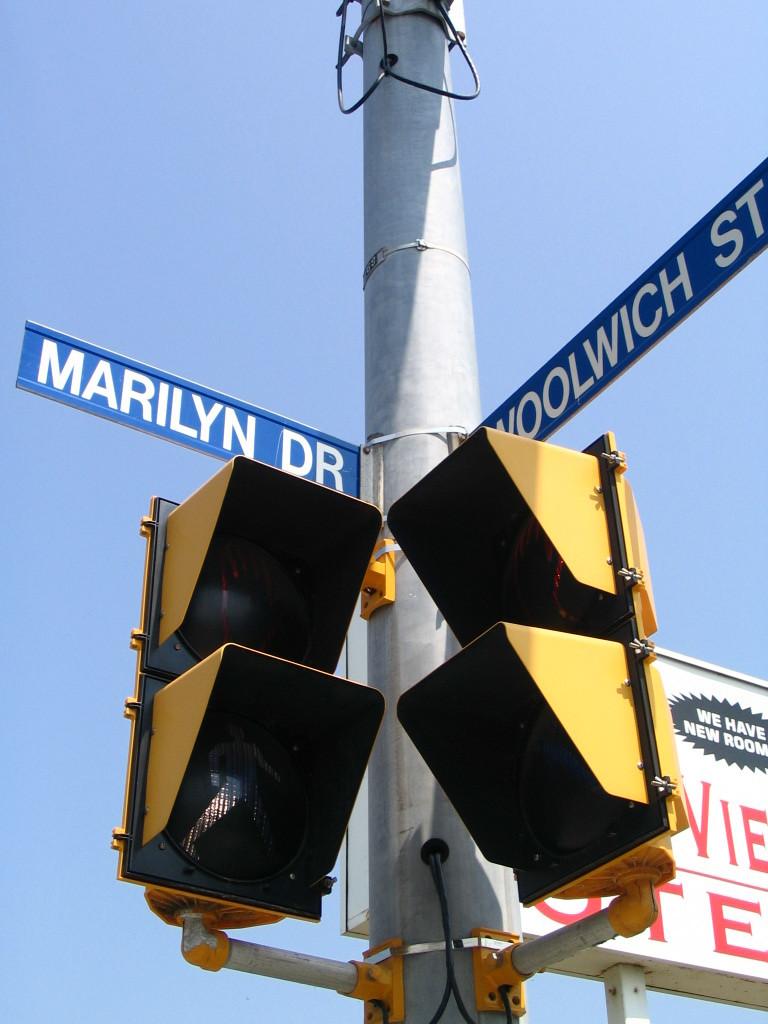What are the street names?
Ensure brevity in your answer.  Marilyn dr and woolwich st. What is in the black bubble on the sign in the back?
Your response must be concise. We have new room. 